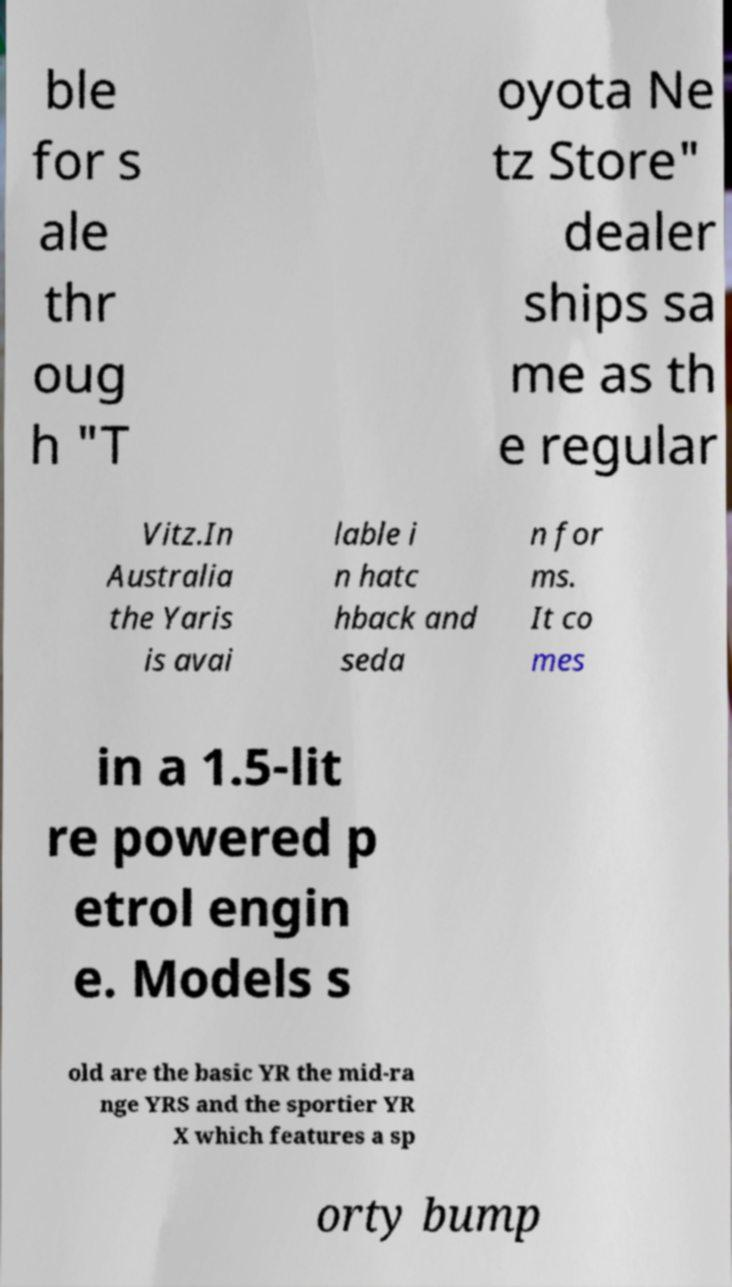Can you read and provide the text displayed in the image?This photo seems to have some interesting text. Can you extract and type it out for me? ble for s ale thr oug h "T oyota Ne tz Store" dealer ships sa me as th e regular Vitz.In Australia the Yaris is avai lable i n hatc hback and seda n for ms. It co mes in a 1.5-lit re powered p etrol engin e. Models s old are the basic YR the mid-ra nge YRS and the sportier YR X which features a sp orty bump 